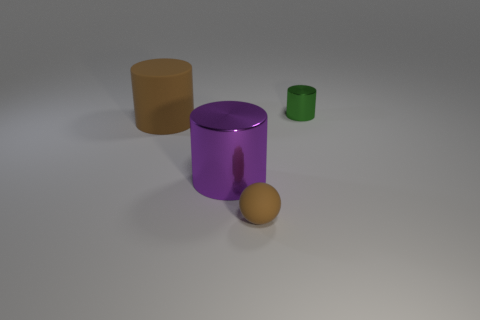What textures are present in the image? The image showcases several objects with distinct textures. The cube and the cylinder have matte surfaces, which diffuse light uniformly, while the ball appears to have a slightly shiny or rubbery texture which reflects light more vividly. 